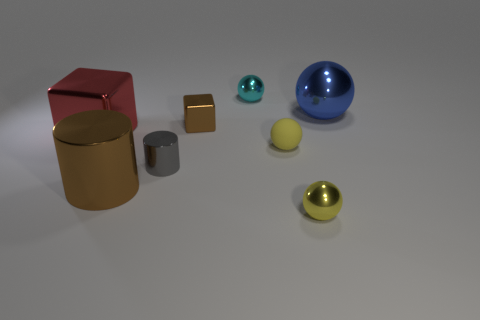Subtract all cyan metal balls. How many balls are left? 3 How many yellow spheres must be subtracted to get 1 yellow spheres? 1 Subtract 1 balls. How many balls are left? 3 Subtract all red cylinders. Subtract all yellow cubes. How many cylinders are left? 2 Subtract all red cubes. How many brown cylinders are left? 1 Subtract all brown cylinders. Subtract all metal cubes. How many objects are left? 5 Add 5 large red metal things. How many large red metal things are left? 6 Add 1 big purple shiny cylinders. How many big purple shiny cylinders exist? 1 Add 2 tiny brown shiny objects. How many objects exist? 10 Subtract all blue spheres. How many spheres are left? 3 